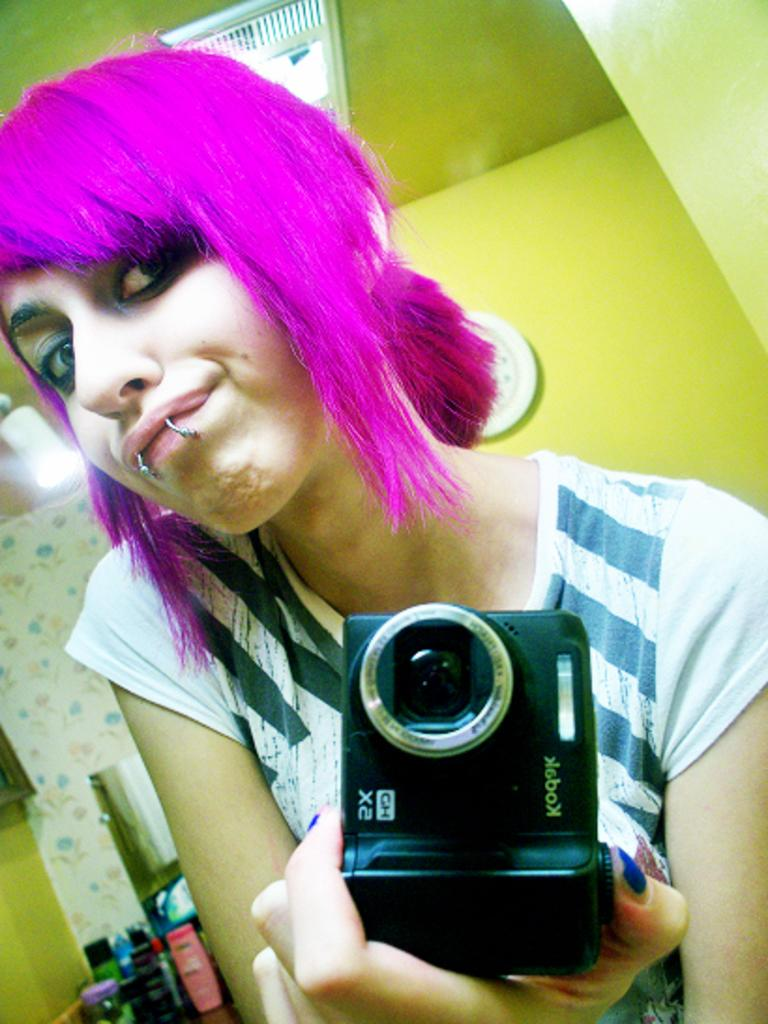Who is the main subject in the image? There is a woman in the image. What is the woman holding in her hand? The woman is holding a camera in her hand. What can be seen in the background of the image? There are bottles, lights, a clock, and a wall in the background of the image. What type of humor can be seen in the woman's expression in the image? There is no indication of humor or any specific expression on the woman's face in the image. 